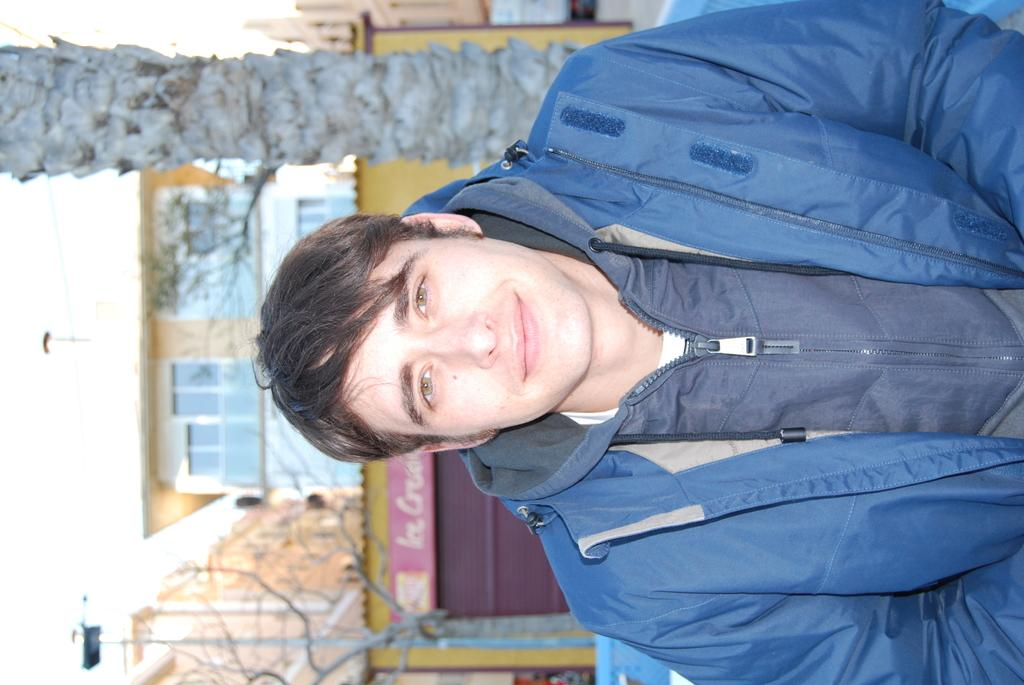What is the person in the image wearing? The person in the image is wearing a dress. What can be seen in the background of the image? There is a group of trees, light poles, a building with windows, a sign board with text, and the sky visible in the background of the image. What type of wine is being served at the reading event in the image? There is no reading event or wine present in the image. 